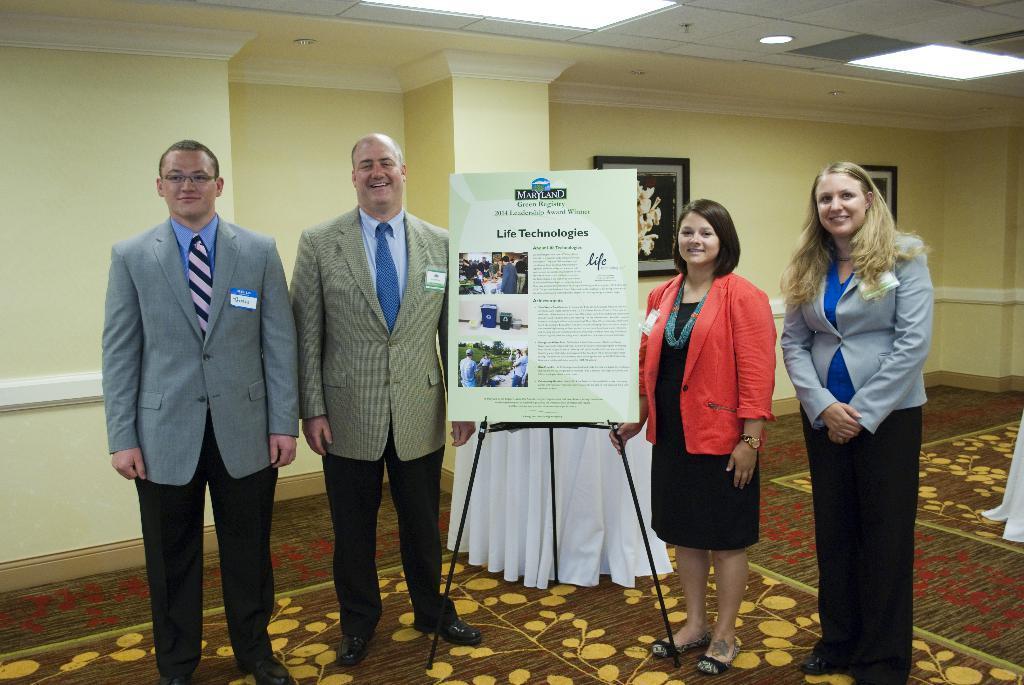Describe this image in one or two sentences. On the left side, we see two men in the blazer are standing. They are smiling and they are posing for the photo. On the right side, we see two women are standing. They are smiling and they are posing for the photo. In the middle, we see a stand and a board with some text written on it. Behind that, we see a sheet in white color. In the background, we see a wall on which the photo frames are placed. At the bottom, we see a carpet in brown color. At the top, we see the lights and the ceiling of the room. 